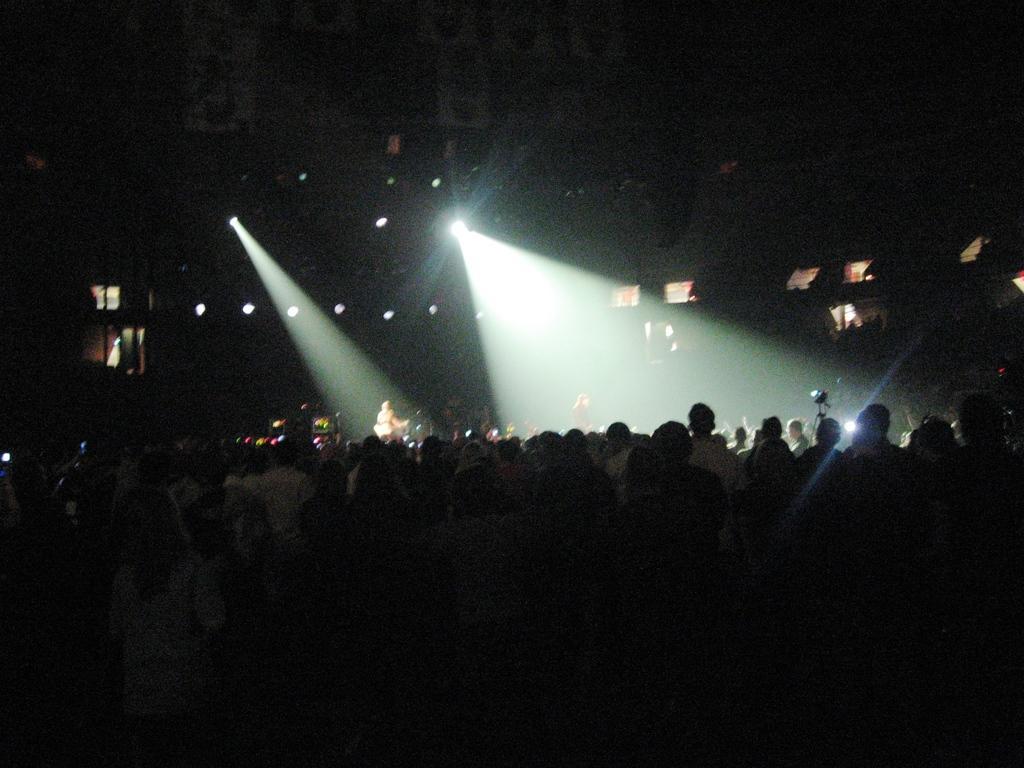Could you give a brief overview of what you see in this image? In this image we can see many people. In the background the image is dark but we can see lights, object on a stand and we can see other objects also. 